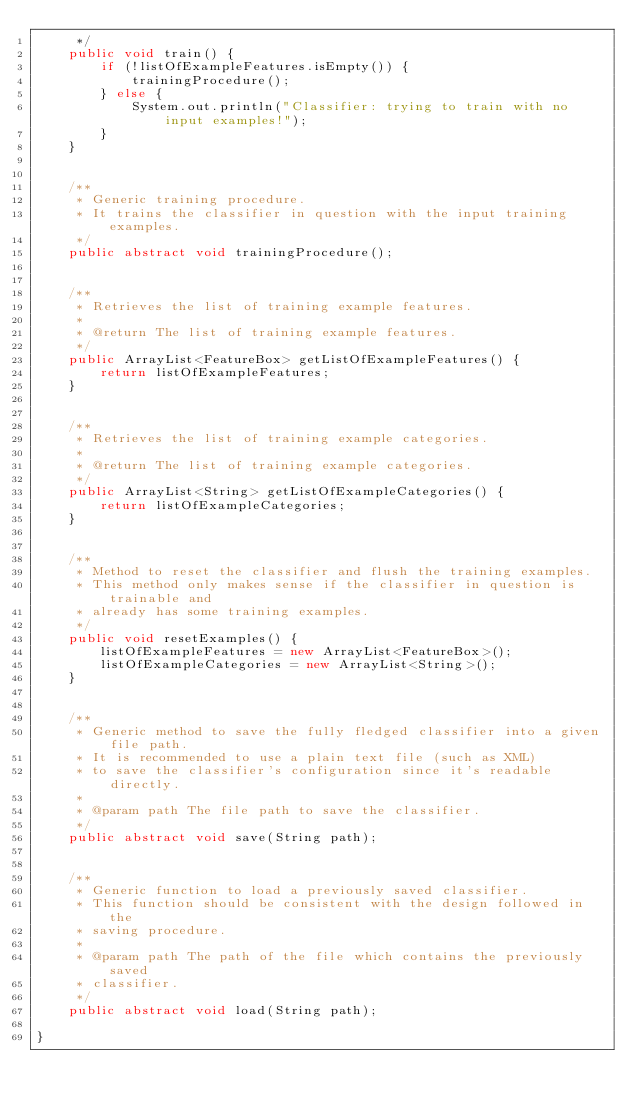<code> <loc_0><loc_0><loc_500><loc_500><_Java_>     */
    public void train() {
        if (!listOfExampleFeatures.isEmpty()) {
            trainingProcedure();
        } else {
            System.out.println("Classifier: trying to train with no input examples!");
        }
    }


    /**
     * Generic training procedure.
     * It trains the classifier in question with the input training examples.
     */
    public abstract void trainingProcedure();


    /**
     * Retrieves the list of training example features.
     *
     * @return The list of training example features.
     */
    public ArrayList<FeatureBox> getListOfExampleFeatures() {
        return listOfExampleFeatures;
    }


    /**
     * Retrieves the list of training example categories.
     *
     * @return The list of training example categories.
     */
    public ArrayList<String> getListOfExampleCategories() {
        return listOfExampleCategories;
    }


    /**
     * Method to reset the classifier and flush the training examples.
     * This method only makes sense if the classifier in question is trainable and
     * already has some training examples.
     */
    public void resetExamples() {
        listOfExampleFeatures = new ArrayList<FeatureBox>();
        listOfExampleCategories = new ArrayList<String>();
    }


    /**
     * Generic method to save the fully fledged classifier into a given file path.
     * It is recommended to use a plain text file (such as XML)
     * to save the classifier's configuration since it's readable directly.
     *
     * @param path The file path to save the classifier.
     */
    public abstract void save(String path);


    /**
     * Generic function to load a previously saved classifier.
     * This function should be consistent with the design followed in the
     * saving procedure.
     *
     * @param path The path of the file which contains the previously saved
     * classifier.
     */
    public abstract void load(String path);

}

</code> 